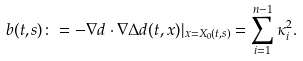Convert formula to latex. <formula><loc_0><loc_0><loc_500><loc_500>b ( t , s ) \colon = - \nabla d \cdot \nabla \Delta d ( t , x ) | _ { x = X _ { 0 } ( t , s ) } = \sum _ { i = 1 } ^ { n - 1 } \kappa _ { i } ^ { 2 } .</formula> 